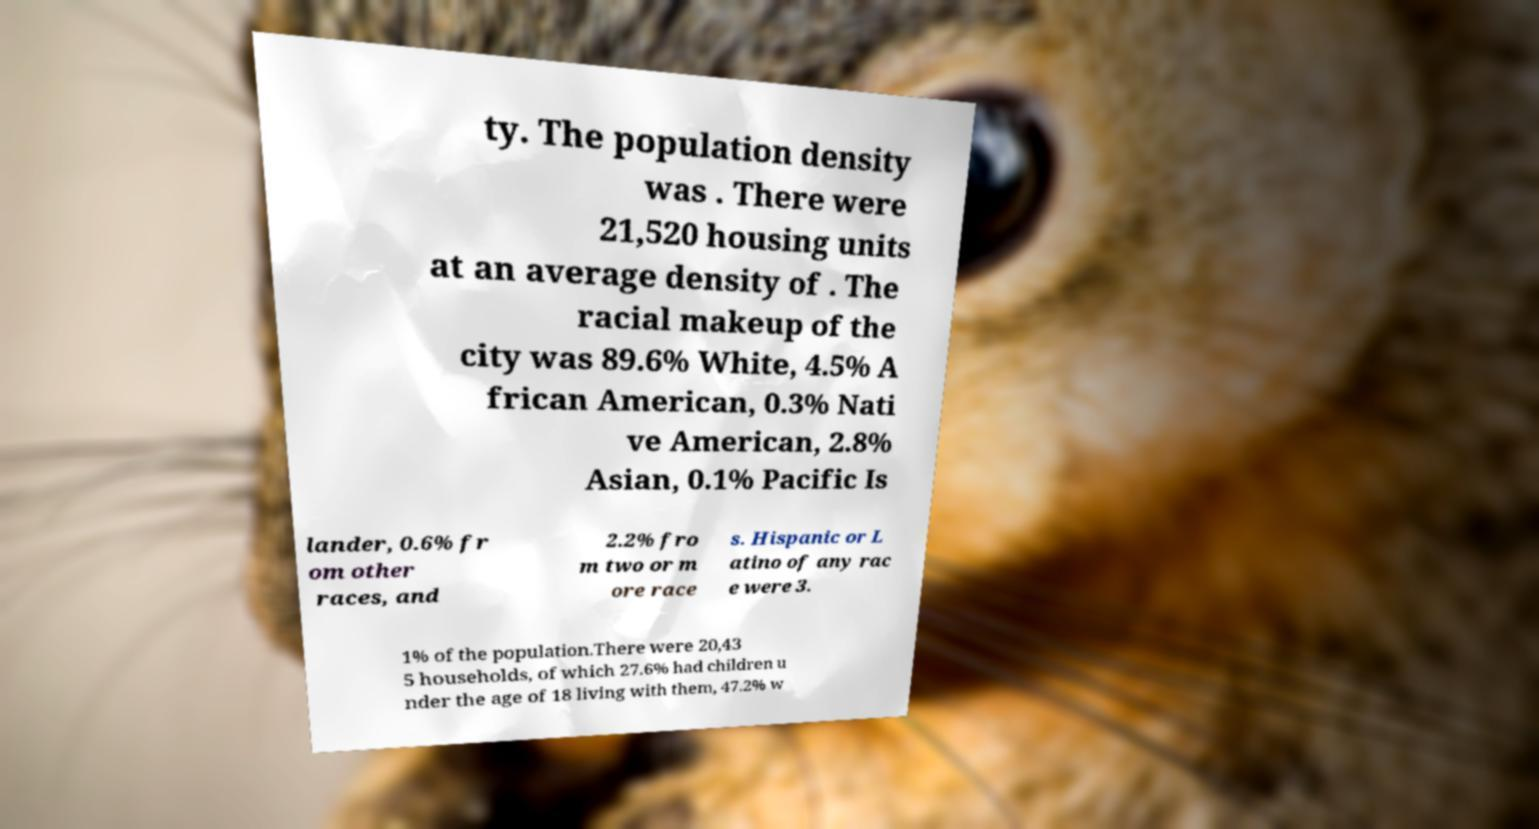I need the written content from this picture converted into text. Can you do that? ty. The population density was . There were 21,520 housing units at an average density of . The racial makeup of the city was 89.6% White, 4.5% A frican American, 0.3% Nati ve American, 2.8% Asian, 0.1% Pacific Is lander, 0.6% fr om other races, and 2.2% fro m two or m ore race s. Hispanic or L atino of any rac e were 3. 1% of the population.There were 20,43 5 households, of which 27.6% had children u nder the age of 18 living with them, 47.2% w 